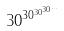Convert formula to latex. <formula><loc_0><loc_0><loc_500><loc_500>3 0 ^ { 3 0 ^ { 3 0 ^ { 3 0 ^ { \dots } } } }</formula> 